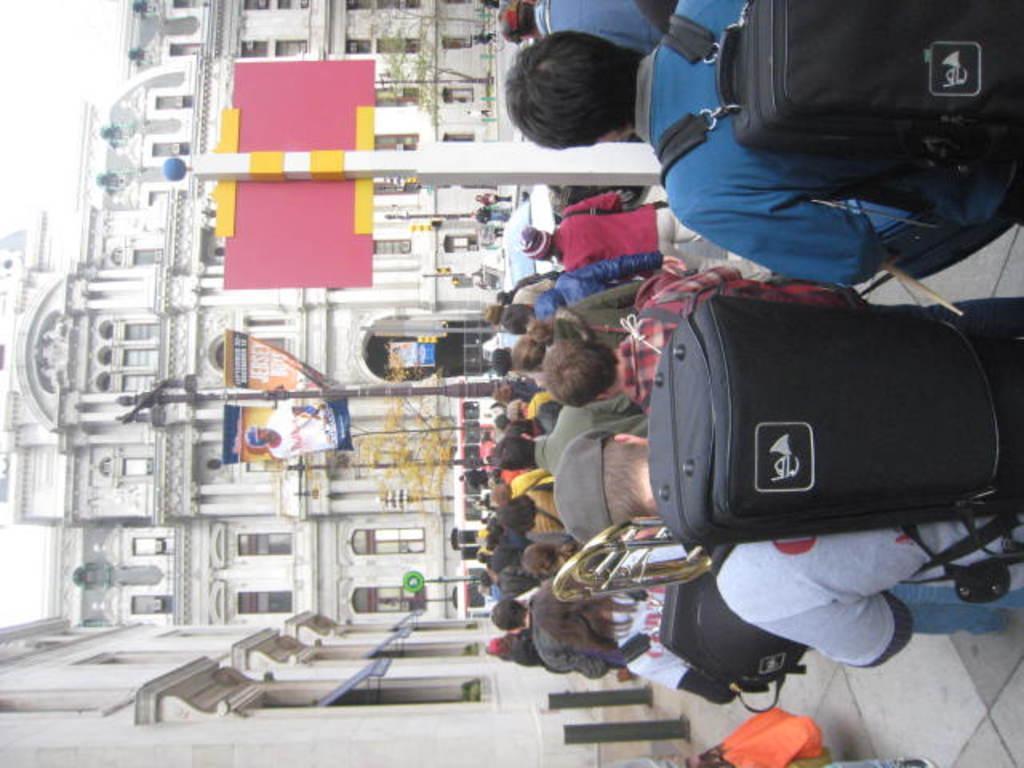Describe this image in one or two sentences. In the image we can see there are many people and they are facing back, they are wearing clothes, some of them wearing caps and carrying bags. Here we can see footpath, poles, posters and text on the posters. Here we can see buildings and windows of the buildings. Here we can see trees and the sky. 